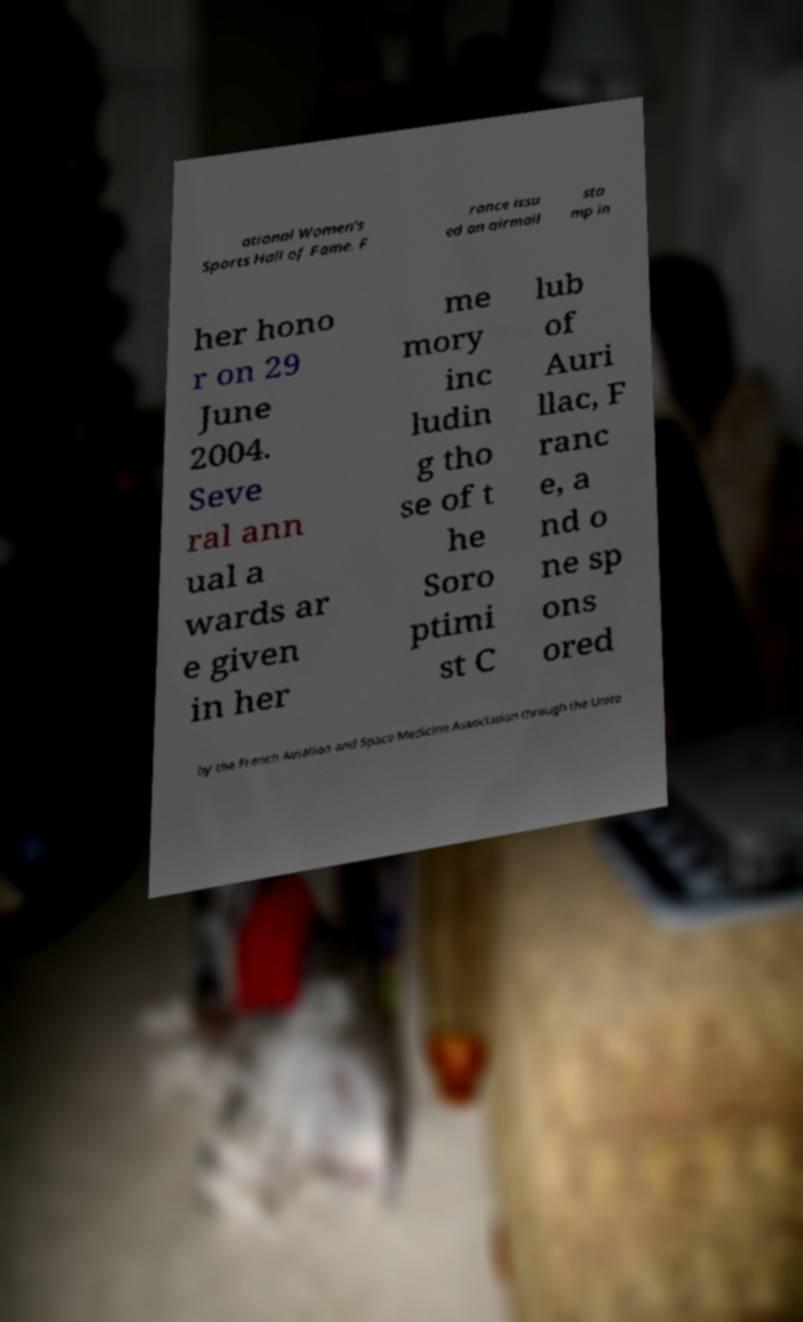Please read and relay the text visible in this image. What does it say? ational Women's Sports Hall of Fame. F rance issu ed an airmail sta mp in her hono r on 29 June 2004. Seve ral ann ual a wards ar e given in her me mory inc ludin g tho se of t he Soro ptimi st C lub of Auri llac, F ranc e, a nd o ne sp ons ored by the French Aviation and Space Medicine Association through the Unite 